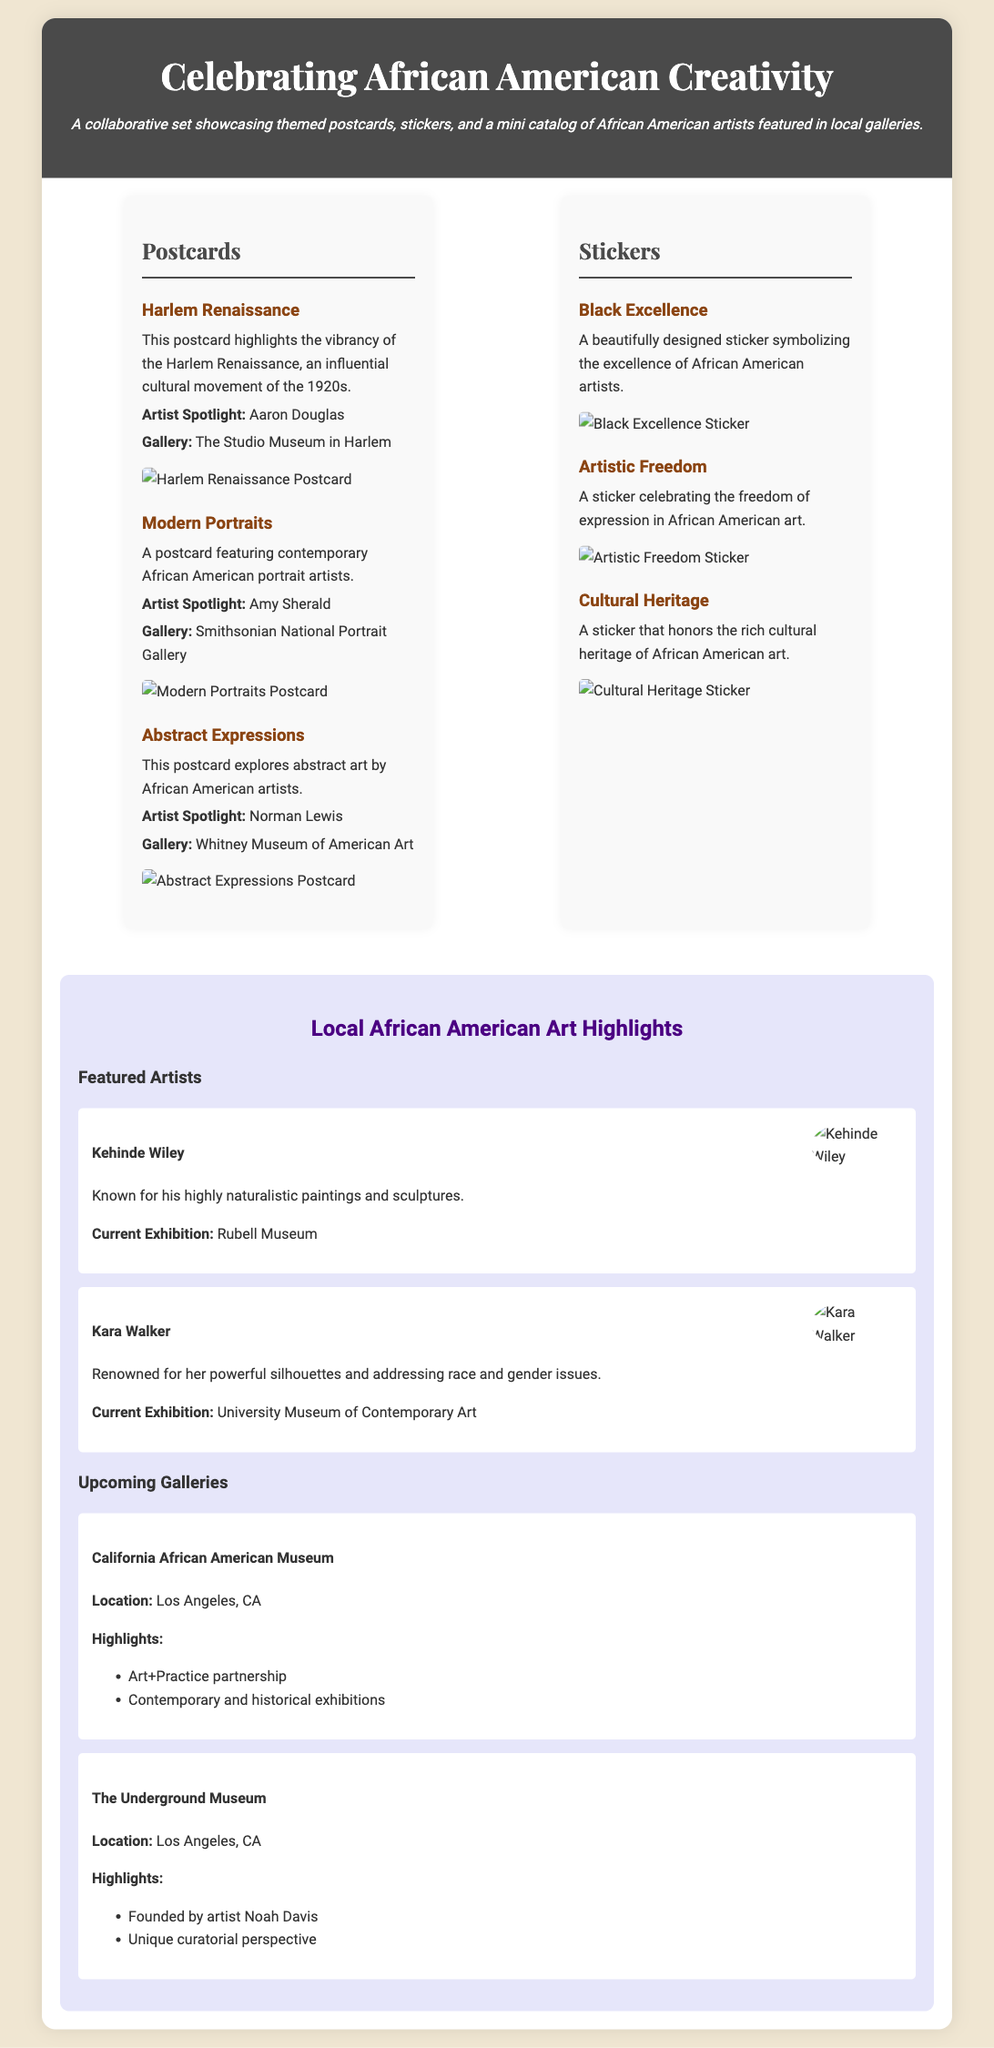What is the main theme of the product packaging? The packaging celebrates African American creativity and showcases related art items.
Answer: African American Creativity Name one artist spotlighted in the postcards section. The section mentions a specific artist who is highlighted on a postcard.
Answer: Aaron Douglas Which gallery features the artist Amy Sherald? The document specifies the gallery associated with Amy Sherald.
Answer: Smithsonian National Portrait Gallery How many stickers are featured in the packaging? The packaging lists a total number of sticker designs presented.
Answer: Three What is the name of a featured artist in the mini catalog? The catalog highlights specific artists, indicating their prominence in local galleries.
Answer: Kehinde Wiley Where is The Underground Museum located? The document provides the location details for this gallery.
Answer: Los Angeles, CA Which postcard highlights the Harlem Renaissance? It identifies a specific postcard design within the collection that focuses on a historical movement.
Answer: Harlem Renaissance What is the design theme of the sticker labeled "Black Excellence"? The description gives insight into the concept that this sticker represents within the art movement.
Answer: Excellence of African American artists What type of items are included in the collaborative set? The packaging specifies categories of items that are part of the set.
Answer: Postcards, stickers, and mini catalog 